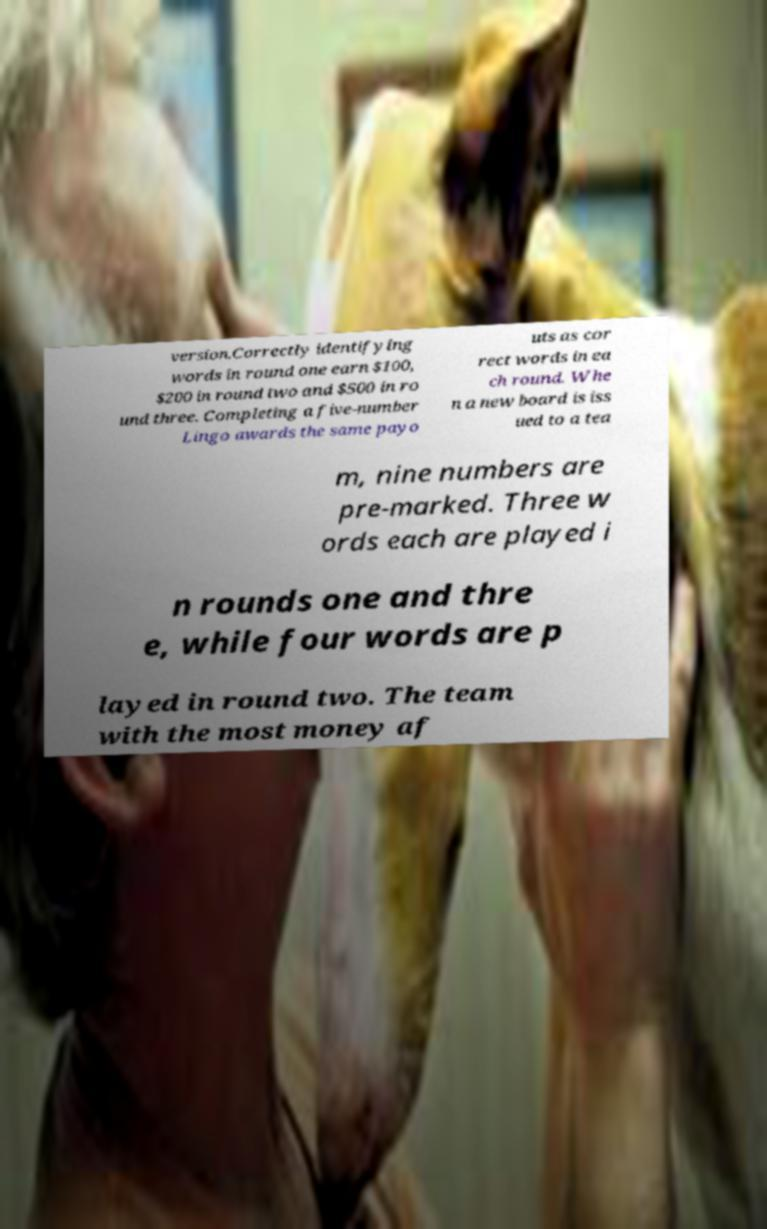Can you read and provide the text displayed in the image?This photo seems to have some interesting text. Can you extract and type it out for me? version.Correctly identifying words in round one earn $100, $200 in round two and $500 in ro und three. Completing a five-number Lingo awards the same payo uts as cor rect words in ea ch round. Whe n a new board is iss ued to a tea m, nine numbers are pre-marked. Three w ords each are played i n rounds one and thre e, while four words are p layed in round two. The team with the most money af 